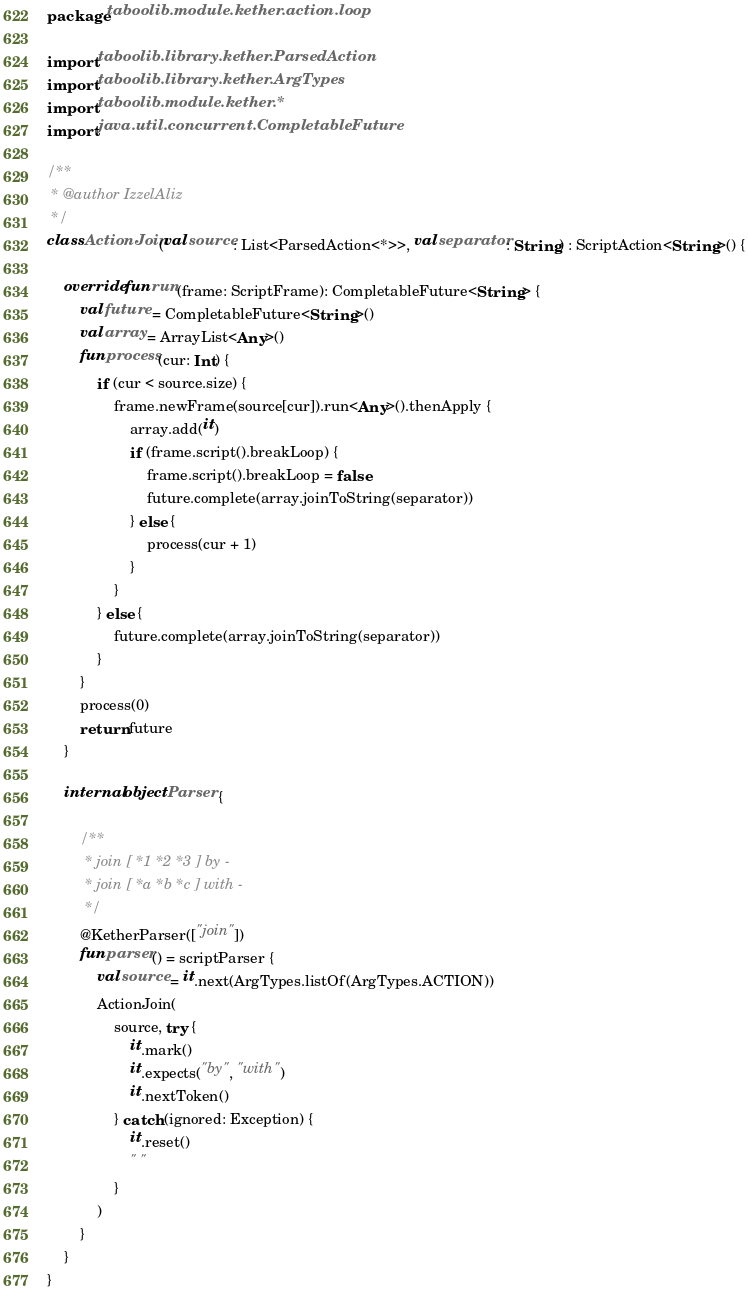<code> <loc_0><loc_0><loc_500><loc_500><_Kotlin_>package taboolib.module.kether.action.loop

import taboolib.library.kether.ParsedAction
import taboolib.library.kether.ArgTypes
import taboolib.module.kether.*
import java.util.concurrent.CompletableFuture

/**
 * @author IzzelAliz
 */
class ActionJoin(val source: List<ParsedAction<*>>, val separator: String) : ScriptAction<String>() {

    override fun run(frame: ScriptFrame): CompletableFuture<String> {
        val future = CompletableFuture<String>()
        val array = ArrayList<Any>()
        fun process(cur: Int) {
            if (cur < source.size) {
                frame.newFrame(source[cur]).run<Any>().thenApply {
                    array.add(it)
                    if (frame.script().breakLoop) {
                        frame.script().breakLoop = false
                        future.complete(array.joinToString(separator))
                    } else {
                        process(cur + 1)
                    }
                }
            } else {
                future.complete(array.joinToString(separator))
            }
        }
        process(0)
        return future
    }

    internal object Parser {

        /**
         * join [ *1 *2 *3 ] by -
         * join [ *a *b *c ] with -
         */
        @KetherParser(["join"])
        fun parser() = scriptParser {
            val source = it.next(ArgTypes.listOf(ArgTypes.ACTION))
            ActionJoin(
                source, try {
                    it.mark()
                    it.expects("by", "with")
                    it.nextToken()
                } catch (ignored: Exception) {
                    it.reset()
                    " "
                }
            )
        }
    }
}</code> 